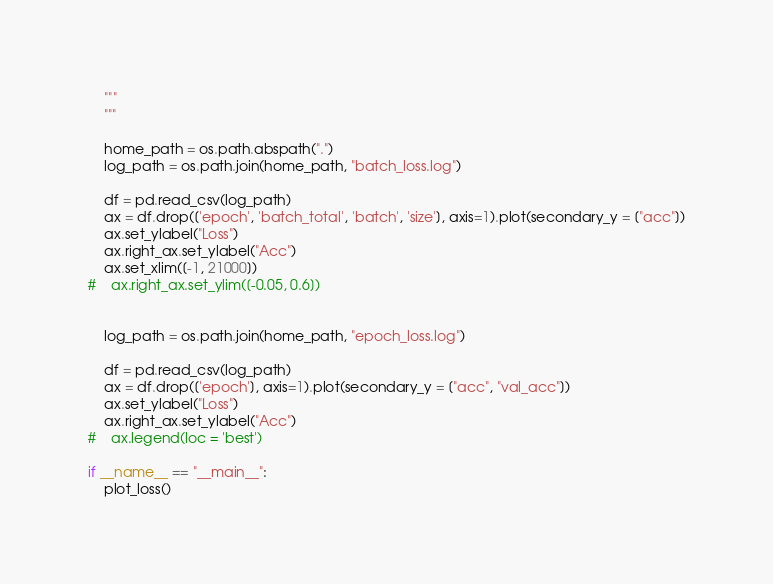<code> <loc_0><loc_0><loc_500><loc_500><_Python_>    """
    """
    
    home_path = os.path.abspath(".")
    log_path = os.path.join(home_path, "batch_loss.log")
    
    df = pd.read_csv(log_path)
    ax = df.drop(['epoch', 'batch_total', 'batch', 'size'], axis=1).plot(secondary_y = ["acc"])
    ax.set_ylabel("Loss")
    ax.right_ax.set_ylabel("Acc")
    ax.set_xlim([-1, 21000])
#    ax.right_ax.set_ylim([-0.05, 0.6])
    
    
    log_path = os.path.join(home_path, "epoch_loss.log")
    
    df = pd.read_csv(log_path)
    ax = df.drop(['epoch'], axis=1).plot(secondary_y = ["acc", "val_acc"])
    ax.set_ylabel("Loss")
    ax.right_ax.set_ylabel("Acc")
#    ax.legend(loc = 'best')
    
if __name__ == "__main__":
    plot_loss()</code> 